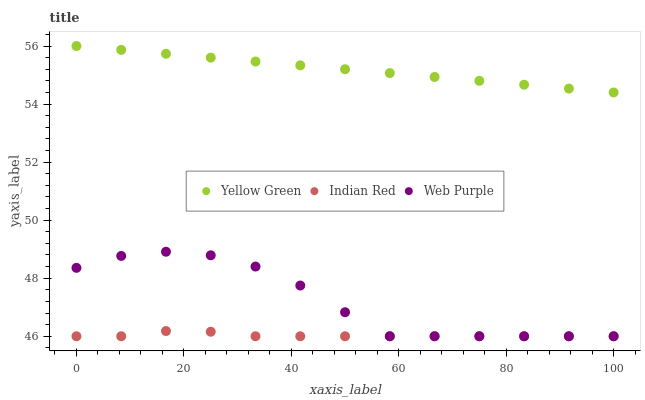Does Indian Red have the minimum area under the curve?
Answer yes or no. Yes. Does Yellow Green have the maximum area under the curve?
Answer yes or no. Yes. Does Yellow Green have the minimum area under the curve?
Answer yes or no. No. Does Indian Red have the maximum area under the curve?
Answer yes or no. No. Is Yellow Green the smoothest?
Answer yes or no. Yes. Is Web Purple the roughest?
Answer yes or no. Yes. Is Indian Red the smoothest?
Answer yes or no. No. Is Indian Red the roughest?
Answer yes or no. No. Does Web Purple have the lowest value?
Answer yes or no. Yes. Does Yellow Green have the lowest value?
Answer yes or no. No. Does Yellow Green have the highest value?
Answer yes or no. Yes. Does Indian Red have the highest value?
Answer yes or no. No. Is Indian Red less than Yellow Green?
Answer yes or no. Yes. Is Yellow Green greater than Web Purple?
Answer yes or no. Yes. Does Web Purple intersect Indian Red?
Answer yes or no. Yes. Is Web Purple less than Indian Red?
Answer yes or no. No. Is Web Purple greater than Indian Red?
Answer yes or no. No. Does Indian Red intersect Yellow Green?
Answer yes or no. No. 